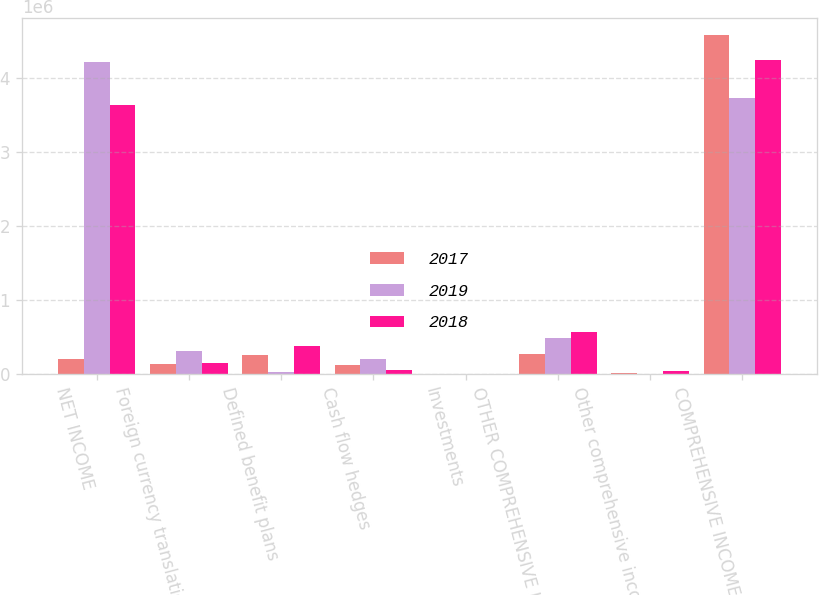Convert chart. <chart><loc_0><loc_0><loc_500><loc_500><stacked_bar_chart><ecel><fcel>NET INCOME<fcel>Foreign currency translation<fcel>Defined benefit plans<fcel>Cash flow hedges<fcel>Investments<fcel>OTHER COMPREHENSIVE INCOME<fcel>Other comprehensive income<fcel>COMPREHENSIVE INCOME<nl><fcel>2017<fcel>198645<fcel>132707<fcel>253039<fcel>123003<fcel>1663<fcel>264406<fcel>6749<fcel>4.57509e+06<nl><fcel>2019<fcel>4.21459e+06<fcel>305225<fcel>21335<fcel>198645<fcel>1148<fcel>481387<fcel>2233<fcel>3.73097e+06<nl><fcel>2018<fcel>3.63493e+06<fcel>149920<fcel>368885<fcel>46624<fcel>1507<fcel>566936<fcel>31724<fcel>4.23359e+06<nl></chart> 